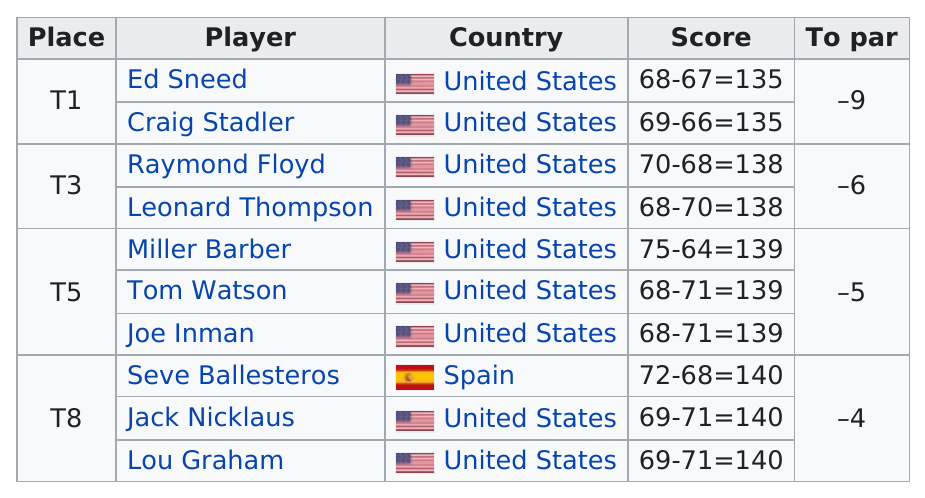Highlight a few significant elements in this photo. Craig Stadler had a higher score than Joe Inman. There were three fifth place winners in the second round of the 1979 Masters Tournament. Based on the given information, there are three players from the United States who have a score of 139. It is known that players Ed Sneed and Craig Stadler have the same score. Out of all the players participating, only 1 player did not hail from the United States. 